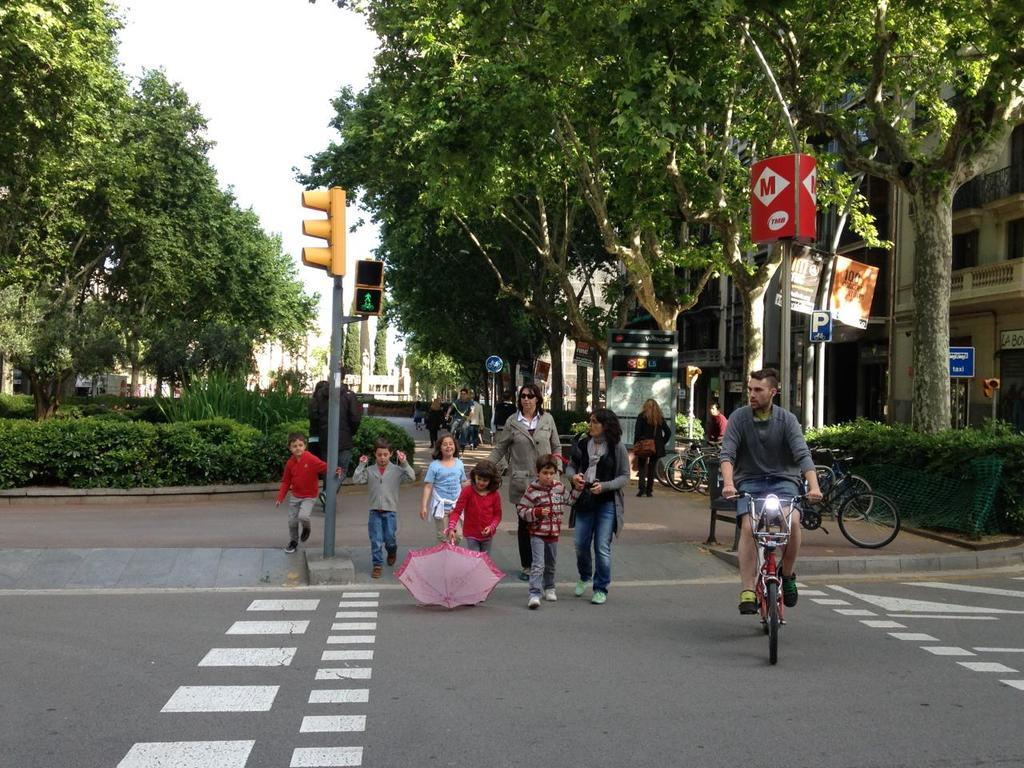Provide a one-sentence caption for the provided image. A group of pedestrians are walking across a street under a red sign with an M on it. 